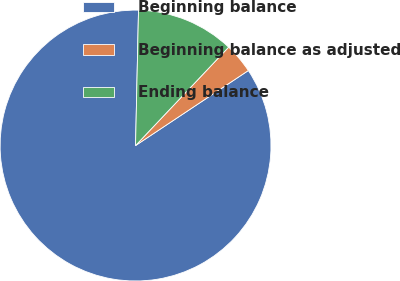Convert chart. <chart><loc_0><loc_0><loc_500><loc_500><pie_chart><fcel>Beginning balance<fcel>Beginning balance as adjusted<fcel>Ending balance<nl><fcel>84.68%<fcel>3.6%<fcel>11.71%<nl></chart> 